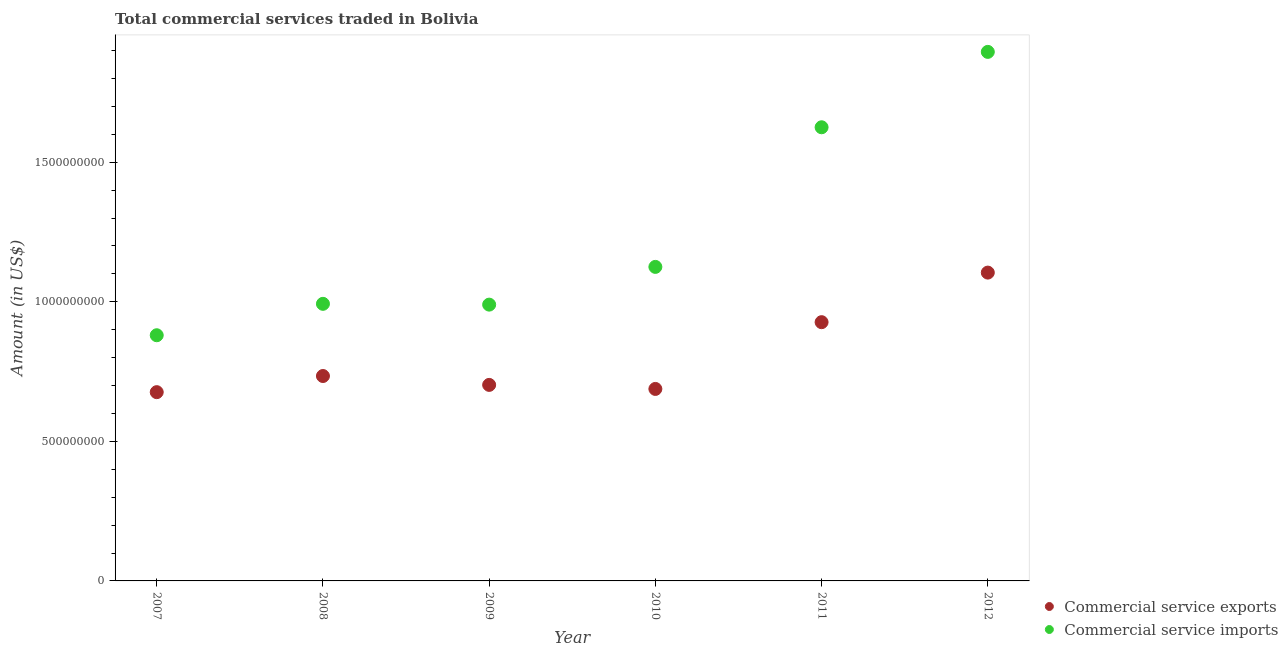How many different coloured dotlines are there?
Give a very brief answer. 2. Is the number of dotlines equal to the number of legend labels?
Your answer should be very brief. Yes. What is the amount of commercial service imports in 2012?
Ensure brevity in your answer.  1.90e+09. Across all years, what is the maximum amount of commercial service imports?
Offer a terse response. 1.90e+09. Across all years, what is the minimum amount of commercial service exports?
Make the answer very short. 6.76e+08. In which year was the amount of commercial service imports maximum?
Your response must be concise. 2012. In which year was the amount of commercial service exports minimum?
Make the answer very short. 2007. What is the total amount of commercial service imports in the graph?
Keep it short and to the point. 7.51e+09. What is the difference between the amount of commercial service exports in 2009 and that in 2010?
Provide a short and direct response. 1.45e+07. What is the difference between the amount of commercial service exports in 2007 and the amount of commercial service imports in 2009?
Offer a very short reply. -3.14e+08. What is the average amount of commercial service imports per year?
Provide a short and direct response. 1.25e+09. In the year 2007, what is the difference between the amount of commercial service imports and amount of commercial service exports?
Your answer should be compact. 2.04e+08. In how many years, is the amount of commercial service exports greater than 1500000000 US$?
Give a very brief answer. 0. What is the ratio of the amount of commercial service imports in 2008 to that in 2011?
Keep it short and to the point. 0.61. What is the difference between the highest and the second highest amount of commercial service exports?
Give a very brief answer. 1.78e+08. What is the difference between the highest and the lowest amount of commercial service exports?
Your answer should be compact. 4.28e+08. Is the sum of the amount of commercial service exports in 2009 and 2010 greater than the maximum amount of commercial service imports across all years?
Your answer should be compact. No. Does the amount of commercial service exports monotonically increase over the years?
Make the answer very short. No. Is the amount of commercial service exports strictly greater than the amount of commercial service imports over the years?
Give a very brief answer. No. Is the amount of commercial service imports strictly less than the amount of commercial service exports over the years?
Make the answer very short. No. How many dotlines are there?
Your response must be concise. 2. Are the values on the major ticks of Y-axis written in scientific E-notation?
Offer a terse response. No. Does the graph contain grids?
Your answer should be compact. No. Where does the legend appear in the graph?
Your answer should be very brief. Bottom right. How many legend labels are there?
Offer a terse response. 2. What is the title of the graph?
Make the answer very short. Total commercial services traded in Bolivia. What is the label or title of the Y-axis?
Your answer should be compact. Amount (in US$). What is the Amount (in US$) in Commercial service exports in 2007?
Offer a terse response. 6.76e+08. What is the Amount (in US$) of Commercial service imports in 2007?
Your response must be concise. 8.80e+08. What is the Amount (in US$) in Commercial service exports in 2008?
Your response must be concise. 7.34e+08. What is the Amount (in US$) of Commercial service imports in 2008?
Give a very brief answer. 9.93e+08. What is the Amount (in US$) of Commercial service exports in 2009?
Provide a short and direct response. 7.02e+08. What is the Amount (in US$) of Commercial service imports in 2009?
Your answer should be very brief. 9.90e+08. What is the Amount (in US$) of Commercial service exports in 2010?
Provide a succinct answer. 6.88e+08. What is the Amount (in US$) of Commercial service imports in 2010?
Provide a short and direct response. 1.13e+09. What is the Amount (in US$) in Commercial service exports in 2011?
Your response must be concise. 9.27e+08. What is the Amount (in US$) in Commercial service imports in 2011?
Keep it short and to the point. 1.63e+09. What is the Amount (in US$) in Commercial service exports in 2012?
Offer a terse response. 1.10e+09. What is the Amount (in US$) in Commercial service imports in 2012?
Provide a succinct answer. 1.90e+09. Across all years, what is the maximum Amount (in US$) in Commercial service exports?
Your response must be concise. 1.10e+09. Across all years, what is the maximum Amount (in US$) of Commercial service imports?
Keep it short and to the point. 1.90e+09. Across all years, what is the minimum Amount (in US$) of Commercial service exports?
Make the answer very short. 6.76e+08. Across all years, what is the minimum Amount (in US$) of Commercial service imports?
Ensure brevity in your answer.  8.80e+08. What is the total Amount (in US$) in Commercial service exports in the graph?
Your answer should be compact. 4.83e+09. What is the total Amount (in US$) in Commercial service imports in the graph?
Your answer should be very brief. 7.51e+09. What is the difference between the Amount (in US$) of Commercial service exports in 2007 and that in 2008?
Offer a terse response. -5.78e+07. What is the difference between the Amount (in US$) of Commercial service imports in 2007 and that in 2008?
Keep it short and to the point. -1.13e+08. What is the difference between the Amount (in US$) in Commercial service exports in 2007 and that in 2009?
Give a very brief answer. -2.60e+07. What is the difference between the Amount (in US$) in Commercial service imports in 2007 and that in 2009?
Your answer should be very brief. -1.10e+08. What is the difference between the Amount (in US$) of Commercial service exports in 2007 and that in 2010?
Ensure brevity in your answer.  -1.15e+07. What is the difference between the Amount (in US$) in Commercial service imports in 2007 and that in 2010?
Ensure brevity in your answer.  -2.45e+08. What is the difference between the Amount (in US$) of Commercial service exports in 2007 and that in 2011?
Your answer should be compact. -2.51e+08. What is the difference between the Amount (in US$) of Commercial service imports in 2007 and that in 2011?
Ensure brevity in your answer.  -7.45e+08. What is the difference between the Amount (in US$) in Commercial service exports in 2007 and that in 2012?
Your answer should be compact. -4.28e+08. What is the difference between the Amount (in US$) of Commercial service imports in 2007 and that in 2012?
Offer a terse response. -1.02e+09. What is the difference between the Amount (in US$) in Commercial service exports in 2008 and that in 2009?
Your answer should be very brief. 3.18e+07. What is the difference between the Amount (in US$) in Commercial service imports in 2008 and that in 2009?
Provide a short and direct response. 2.86e+06. What is the difference between the Amount (in US$) of Commercial service exports in 2008 and that in 2010?
Provide a short and direct response. 4.63e+07. What is the difference between the Amount (in US$) of Commercial service imports in 2008 and that in 2010?
Your answer should be compact. -1.32e+08. What is the difference between the Amount (in US$) of Commercial service exports in 2008 and that in 2011?
Your response must be concise. -1.93e+08. What is the difference between the Amount (in US$) in Commercial service imports in 2008 and that in 2011?
Your answer should be very brief. -6.33e+08. What is the difference between the Amount (in US$) of Commercial service exports in 2008 and that in 2012?
Offer a very short reply. -3.70e+08. What is the difference between the Amount (in US$) in Commercial service imports in 2008 and that in 2012?
Offer a very short reply. -9.03e+08. What is the difference between the Amount (in US$) in Commercial service exports in 2009 and that in 2010?
Your response must be concise. 1.45e+07. What is the difference between the Amount (in US$) of Commercial service imports in 2009 and that in 2010?
Keep it short and to the point. -1.35e+08. What is the difference between the Amount (in US$) of Commercial service exports in 2009 and that in 2011?
Your response must be concise. -2.25e+08. What is the difference between the Amount (in US$) in Commercial service imports in 2009 and that in 2011?
Your answer should be very brief. -6.35e+08. What is the difference between the Amount (in US$) of Commercial service exports in 2009 and that in 2012?
Make the answer very short. -4.02e+08. What is the difference between the Amount (in US$) of Commercial service imports in 2009 and that in 2012?
Make the answer very short. -9.05e+08. What is the difference between the Amount (in US$) in Commercial service exports in 2010 and that in 2011?
Ensure brevity in your answer.  -2.39e+08. What is the difference between the Amount (in US$) in Commercial service imports in 2010 and that in 2011?
Your answer should be very brief. -5.00e+08. What is the difference between the Amount (in US$) in Commercial service exports in 2010 and that in 2012?
Your response must be concise. -4.17e+08. What is the difference between the Amount (in US$) of Commercial service imports in 2010 and that in 2012?
Give a very brief answer. -7.70e+08. What is the difference between the Amount (in US$) of Commercial service exports in 2011 and that in 2012?
Keep it short and to the point. -1.78e+08. What is the difference between the Amount (in US$) of Commercial service imports in 2011 and that in 2012?
Ensure brevity in your answer.  -2.70e+08. What is the difference between the Amount (in US$) of Commercial service exports in 2007 and the Amount (in US$) of Commercial service imports in 2008?
Your response must be concise. -3.16e+08. What is the difference between the Amount (in US$) in Commercial service exports in 2007 and the Amount (in US$) in Commercial service imports in 2009?
Give a very brief answer. -3.14e+08. What is the difference between the Amount (in US$) in Commercial service exports in 2007 and the Amount (in US$) in Commercial service imports in 2010?
Give a very brief answer. -4.49e+08. What is the difference between the Amount (in US$) in Commercial service exports in 2007 and the Amount (in US$) in Commercial service imports in 2011?
Provide a succinct answer. -9.49e+08. What is the difference between the Amount (in US$) in Commercial service exports in 2007 and the Amount (in US$) in Commercial service imports in 2012?
Provide a succinct answer. -1.22e+09. What is the difference between the Amount (in US$) in Commercial service exports in 2008 and the Amount (in US$) in Commercial service imports in 2009?
Keep it short and to the point. -2.56e+08. What is the difference between the Amount (in US$) in Commercial service exports in 2008 and the Amount (in US$) in Commercial service imports in 2010?
Your response must be concise. -3.91e+08. What is the difference between the Amount (in US$) in Commercial service exports in 2008 and the Amount (in US$) in Commercial service imports in 2011?
Your answer should be compact. -8.91e+08. What is the difference between the Amount (in US$) in Commercial service exports in 2008 and the Amount (in US$) in Commercial service imports in 2012?
Offer a very short reply. -1.16e+09. What is the difference between the Amount (in US$) of Commercial service exports in 2009 and the Amount (in US$) of Commercial service imports in 2010?
Make the answer very short. -4.23e+08. What is the difference between the Amount (in US$) in Commercial service exports in 2009 and the Amount (in US$) in Commercial service imports in 2011?
Offer a terse response. -9.23e+08. What is the difference between the Amount (in US$) of Commercial service exports in 2009 and the Amount (in US$) of Commercial service imports in 2012?
Offer a terse response. -1.19e+09. What is the difference between the Amount (in US$) of Commercial service exports in 2010 and the Amount (in US$) of Commercial service imports in 2011?
Provide a succinct answer. -9.37e+08. What is the difference between the Amount (in US$) in Commercial service exports in 2010 and the Amount (in US$) in Commercial service imports in 2012?
Provide a short and direct response. -1.21e+09. What is the difference between the Amount (in US$) of Commercial service exports in 2011 and the Amount (in US$) of Commercial service imports in 2012?
Keep it short and to the point. -9.68e+08. What is the average Amount (in US$) of Commercial service exports per year?
Your answer should be compact. 8.05e+08. What is the average Amount (in US$) of Commercial service imports per year?
Give a very brief answer. 1.25e+09. In the year 2007, what is the difference between the Amount (in US$) in Commercial service exports and Amount (in US$) in Commercial service imports?
Keep it short and to the point. -2.04e+08. In the year 2008, what is the difference between the Amount (in US$) in Commercial service exports and Amount (in US$) in Commercial service imports?
Make the answer very short. -2.59e+08. In the year 2009, what is the difference between the Amount (in US$) of Commercial service exports and Amount (in US$) of Commercial service imports?
Your answer should be very brief. -2.88e+08. In the year 2010, what is the difference between the Amount (in US$) in Commercial service exports and Amount (in US$) in Commercial service imports?
Provide a short and direct response. -4.37e+08. In the year 2011, what is the difference between the Amount (in US$) in Commercial service exports and Amount (in US$) in Commercial service imports?
Your answer should be very brief. -6.98e+08. In the year 2012, what is the difference between the Amount (in US$) of Commercial service exports and Amount (in US$) of Commercial service imports?
Offer a terse response. -7.91e+08. What is the ratio of the Amount (in US$) of Commercial service exports in 2007 to that in 2008?
Make the answer very short. 0.92. What is the ratio of the Amount (in US$) in Commercial service imports in 2007 to that in 2008?
Your answer should be compact. 0.89. What is the ratio of the Amount (in US$) of Commercial service exports in 2007 to that in 2009?
Ensure brevity in your answer.  0.96. What is the ratio of the Amount (in US$) in Commercial service imports in 2007 to that in 2009?
Your response must be concise. 0.89. What is the ratio of the Amount (in US$) in Commercial service exports in 2007 to that in 2010?
Give a very brief answer. 0.98. What is the ratio of the Amount (in US$) of Commercial service imports in 2007 to that in 2010?
Keep it short and to the point. 0.78. What is the ratio of the Amount (in US$) of Commercial service exports in 2007 to that in 2011?
Make the answer very short. 0.73. What is the ratio of the Amount (in US$) in Commercial service imports in 2007 to that in 2011?
Offer a terse response. 0.54. What is the ratio of the Amount (in US$) of Commercial service exports in 2007 to that in 2012?
Offer a terse response. 0.61. What is the ratio of the Amount (in US$) in Commercial service imports in 2007 to that in 2012?
Provide a succinct answer. 0.46. What is the ratio of the Amount (in US$) in Commercial service exports in 2008 to that in 2009?
Offer a terse response. 1.05. What is the ratio of the Amount (in US$) in Commercial service exports in 2008 to that in 2010?
Offer a terse response. 1.07. What is the ratio of the Amount (in US$) in Commercial service imports in 2008 to that in 2010?
Keep it short and to the point. 0.88. What is the ratio of the Amount (in US$) in Commercial service exports in 2008 to that in 2011?
Give a very brief answer. 0.79. What is the ratio of the Amount (in US$) of Commercial service imports in 2008 to that in 2011?
Your response must be concise. 0.61. What is the ratio of the Amount (in US$) in Commercial service exports in 2008 to that in 2012?
Your response must be concise. 0.66. What is the ratio of the Amount (in US$) in Commercial service imports in 2008 to that in 2012?
Provide a short and direct response. 0.52. What is the ratio of the Amount (in US$) of Commercial service exports in 2009 to that in 2010?
Offer a terse response. 1.02. What is the ratio of the Amount (in US$) in Commercial service imports in 2009 to that in 2010?
Ensure brevity in your answer.  0.88. What is the ratio of the Amount (in US$) in Commercial service exports in 2009 to that in 2011?
Your response must be concise. 0.76. What is the ratio of the Amount (in US$) of Commercial service imports in 2009 to that in 2011?
Give a very brief answer. 0.61. What is the ratio of the Amount (in US$) in Commercial service exports in 2009 to that in 2012?
Give a very brief answer. 0.64. What is the ratio of the Amount (in US$) of Commercial service imports in 2009 to that in 2012?
Offer a terse response. 0.52. What is the ratio of the Amount (in US$) in Commercial service exports in 2010 to that in 2011?
Give a very brief answer. 0.74. What is the ratio of the Amount (in US$) in Commercial service imports in 2010 to that in 2011?
Offer a terse response. 0.69. What is the ratio of the Amount (in US$) of Commercial service exports in 2010 to that in 2012?
Provide a short and direct response. 0.62. What is the ratio of the Amount (in US$) in Commercial service imports in 2010 to that in 2012?
Your answer should be compact. 0.59. What is the ratio of the Amount (in US$) of Commercial service exports in 2011 to that in 2012?
Give a very brief answer. 0.84. What is the ratio of the Amount (in US$) in Commercial service imports in 2011 to that in 2012?
Provide a short and direct response. 0.86. What is the difference between the highest and the second highest Amount (in US$) of Commercial service exports?
Offer a terse response. 1.78e+08. What is the difference between the highest and the second highest Amount (in US$) of Commercial service imports?
Provide a succinct answer. 2.70e+08. What is the difference between the highest and the lowest Amount (in US$) in Commercial service exports?
Provide a short and direct response. 4.28e+08. What is the difference between the highest and the lowest Amount (in US$) of Commercial service imports?
Offer a terse response. 1.02e+09. 